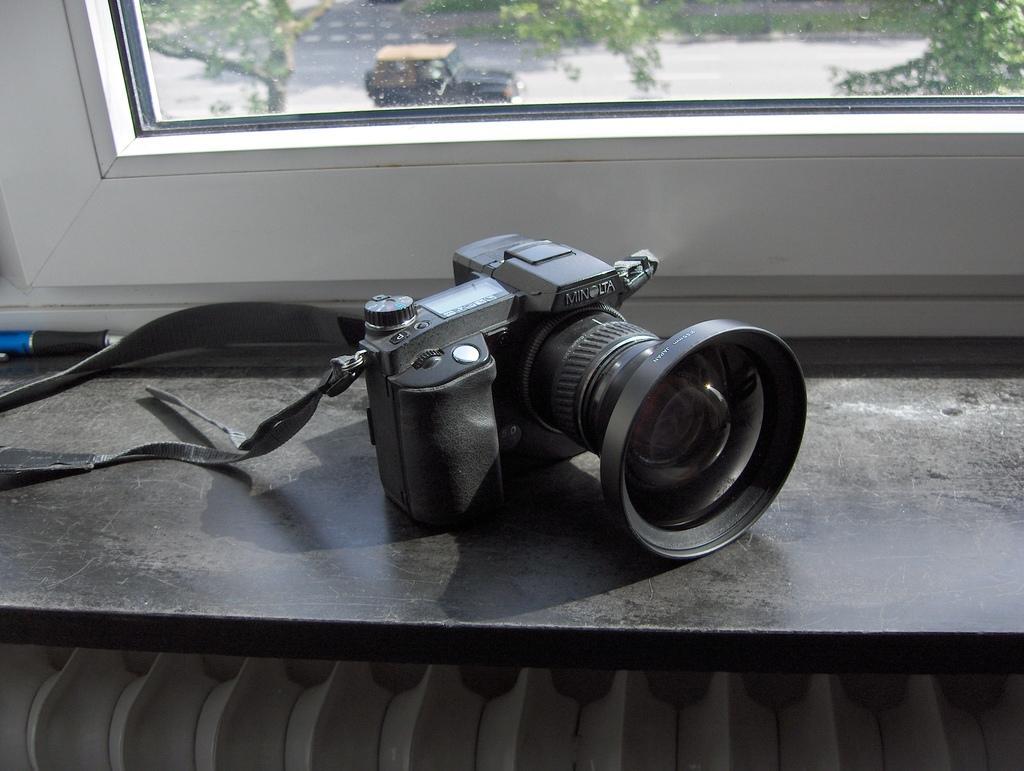Could you give a brief overview of what you see in this image? There is a camera and a pen. There is a window through which we can see trees and a vehicle on the road. 